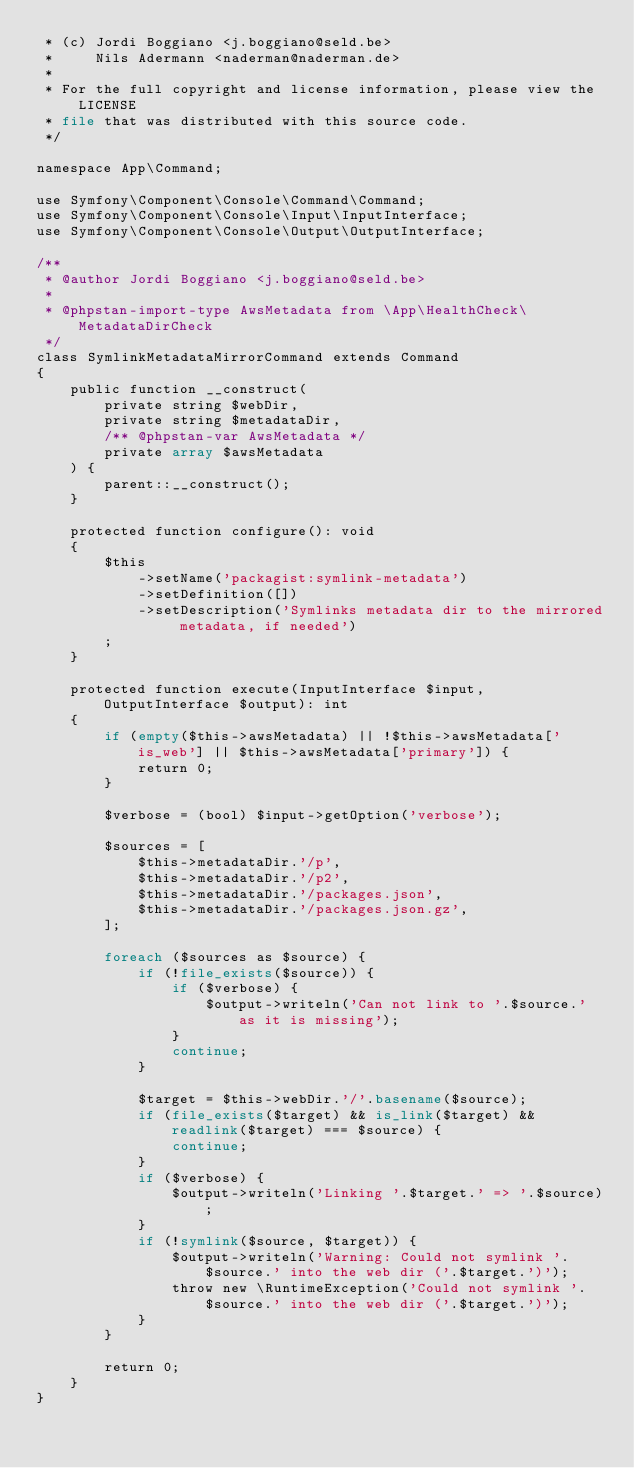Convert code to text. <code><loc_0><loc_0><loc_500><loc_500><_PHP_> * (c) Jordi Boggiano <j.boggiano@seld.be>
 *     Nils Adermann <naderman@naderman.de>
 *
 * For the full copyright and license information, please view the LICENSE
 * file that was distributed with this source code.
 */

namespace App\Command;

use Symfony\Component\Console\Command\Command;
use Symfony\Component\Console\Input\InputInterface;
use Symfony\Component\Console\Output\OutputInterface;

/**
 * @author Jordi Boggiano <j.boggiano@seld.be>
 *
 * @phpstan-import-type AwsMetadata from \App\HealthCheck\MetadataDirCheck
 */
class SymlinkMetadataMirrorCommand extends Command
{
    public function __construct(
        private string $webDir,
        private string $metadataDir,
        /** @phpstan-var AwsMetadata */
        private array $awsMetadata
    ) {
        parent::__construct();
    }

    protected function configure(): void
    {
        $this
            ->setName('packagist:symlink-metadata')
            ->setDefinition([])
            ->setDescription('Symlinks metadata dir to the mirrored metadata, if needed')
        ;
    }

    protected function execute(InputInterface $input, OutputInterface $output): int
    {
        if (empty($this->awsMetadata) || !$this->awsMetadata['is_web'] || $this->awsMetadata['primary']) {
            return 0;
        }

        $verbose = (bool) $input->getOption('verbose');

        $sources = [
            $this->metadataDir.'/p',
            $this->metadataDir.'/p2',
            $this->metadataDir.'/packages.json',
            $this->metadataDir.'/packages.json.gz',
        ];

        foreach ($sources as $source) {
            if (!file_exists($source)) {
                if ($verbose) {
                    $output->writeln('Can not link to '.$source.' as it is missing');
                }
                continue;
            }

            $target = $this->webDir.'/'.basename($source);
            if (file_exists($target) && is_link($target) && readlink($target) === $source) {
                continue;
            }
            if ($verbose) {
                $output->writeln('Linking '.$target.' => '.$source);
            }
            if (!symlink($source, $target)) {
                $output->writeln('Warning: Could not symlink '.$source.' into the web dir ('.$target.')');
                throw new \RuntimeException('Could not symlink '.$source.' into the web dir ('.$target.')');
            }
        }

        return 0;
    }
}
</code> 